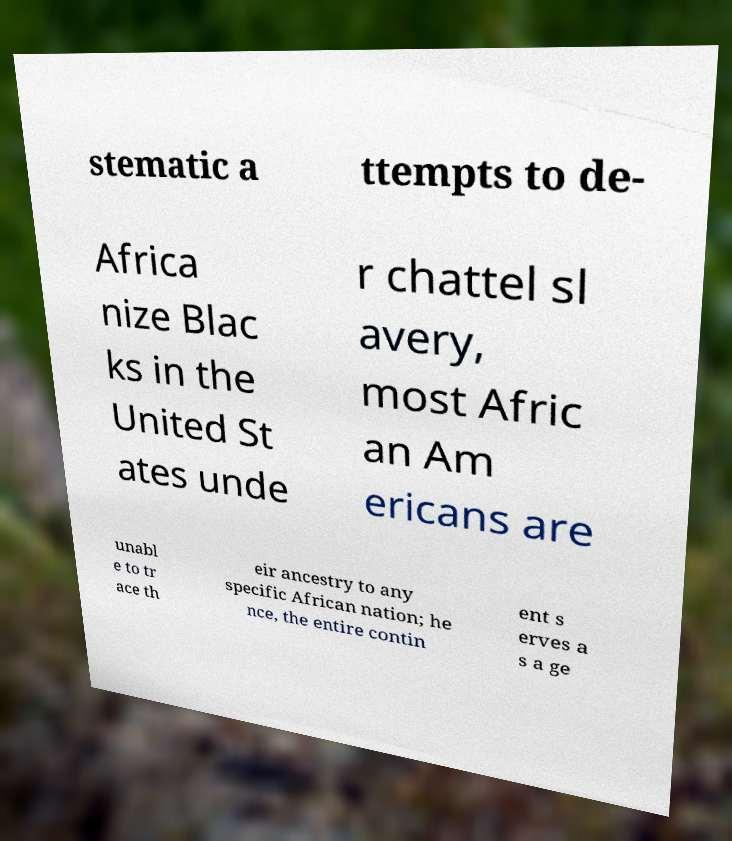Could you extract and type out the text from this image? stematic a ttempts to de- Africa nize Blac ks in the United St ates unde r chattel sl avery, most Afric an Am ericans are unabl e to tr ace th eir ancestry to any specific African nation; he nce, the entire contin ent s erves a s a ge 